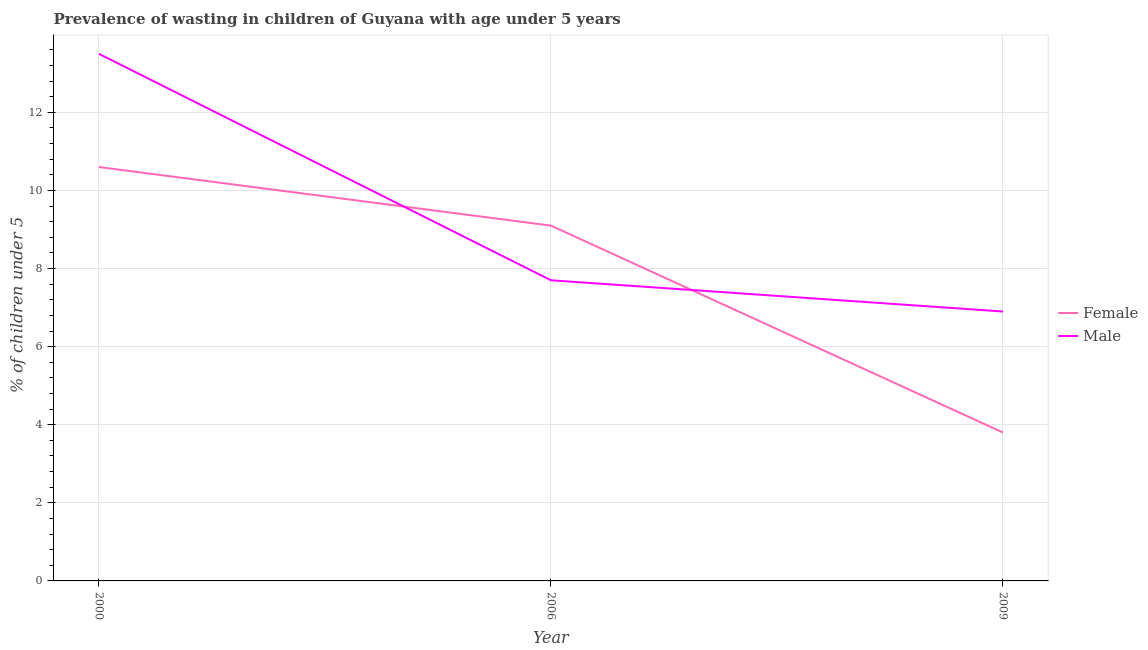Is the number of lines equal to the number of legend labels?
Offer a terse response. Yes. What is the percentage of undernourished male children in 2009?
Ensure brevity in your answer.  6.9. Across all years, what is the maximum percentage of undernourished male children?
Your answer should be compact. 13.5. Across all years, what is the minimum percentage of undernourished female children?
Give a very brief answer. 3.8. In which year was the percentage of undernourished male children minimum?
Provide a short and direct response. 2009. What is the total percentage of undernourished female children in the graph?
Keep it short and to the point. 23.5. What is the difference between the percentage of undernourished female children in 2000 and that in 2006?
Give a very brief answer. 1.5. What is the difference between the percentage of undernourished male children in 2006 and the percentage of undernourished female children in 2000?
Provide a succinct answer. -2.9. What is the average percentage of undernourished female children per year?
Give a very brief answer. 7.83. In the year 2006, what is the difference between the percentage of undernourished male children and percentage of undernourished female children?
Your answer should be very brief. -1.4. What is the ratio of the percentage of undernourished male children in 2000 to that in 2009?
Ensure brevity in your answer.  1.96. Is the percentage of undernourished female children in 2000 less than that in 2006?
Ensure brevity in your answer.  No. What is the difference between the highest and the second highest percentage of undernourished male children?
Keep it short and to the point. 5.8. What is the difference between the highest and the lowest percentage of undernourished male children?
Keep it short and to the point. 6.6. In how many years, is the percentage of undernourished male children greater than the average percentage of undernourished male children taken over all years?
Your response must be concise. 1. Is the sum of the percentage of undernourished female children in 2000 and 2009 greater than the maximum percentage of undernourished male children across all years?
Your response must be concise. Yes. Does the percentage of undernourished male children monotonically increase over the years?
Make the answer very short. No. Is the percentage of undernourished male children strictly greater than the percentage of undernourished female children over the years?
Your answer should be compact. No. Is the percentage of undernourished male children strictly less than the percentage of undernourished female children over the years?
Make the answer very short. No. How many years are there in the graph?
Your answer should be compact. 3. What is the difference between two consecutive major ticks on the Y-axis?
Offer a terse response. 2. Does the graph contain grids?
Your answer should be very brief. Yes. Where does the legend appear in the graph?
Keep it short and to the point. Center right. How many legend labels are there?
Offer a very short reply. 2. What is the title of the graph?
Offer a very short reply. Prevalence of wasting in children of Guyana with age under 5 years. Does "Electricity and heat production" appear as one of the legend labels in the graph?
Offer a very short reply. No. What is the label or title of the Y-axis?
Your answer should be compact.  % of children under 5. What is the  % of children under 5 of Female in 2000?
Offer a terse response. 10.6. What is the  % of children under 5 in Female in 2006?
Give a very brief answer. 9.1. What is the  % of children under 5 of Male in 2006?
Keep it short and to the point. 7.7. What is the  % of children under 5 in Female in 2009?
Keep it short and to the point. 3.8. What is the  % of children under 5 in Male in 2009?
Your answer should be very brief. 6.9. Across all years, what is the maximum  % of children under 5 of Female?
Your answer should be compact. 10.6. Across all years, what is the minimum  % of children under 5 of Female?
Provide a succinct answer. 3.8. Across all years, what is the minimum  % of children under 5 in Male?
Provide a succinct answer. 6.9. What is the total  % of children under 5 of Male in the graph?
Make the answer very short. 28.1. What is the difference between the  % of children under 5 in Male in 2000 and that in 2006?
Give a very brief answer. 5.8. What is the difference between the  % of children under 5 of Female in 2000 and that in 2009?
Make the answer very short. 6.8. What is the difference between the  % of children under 5 of Male in 2006 and that in 2009?
Provide a succinct answer. 0.8. What is the average  % of children under 5 of Female per year?
Keep it short and to the point. 7.83. What is the average  % of children under 5 in Male per year?
Provide a succinct answer. 9.37. In the year 2006, what is the difference between the  % of children under 5 of Female and  % of children under 5 of Male?
Give a very brief answer. 1.4. In the year 2009, what is the difference between the  % of children under 5 of Female and  % of children under 5 of Male?
Keep it short and to the point. -3.1. What is the ratio of the  % of children under 5 of Female in 2000 to that in 2006?
Give a very brief answer. 1.16. What is the ratio of the  % of children under 5 of Male in 2000 to that in 2006?
Your answer should be compact. 1.75. What is the ratio of the  % of children under 5 in Female in 2000 to that in 2009?
Offer a terse response. 2.79. What is the ratio of the  % of children under 5 of Male in 2000 to that in 2009?
Give a very brief answer. 1.96. What is the ratio of the  % of children under 5 of Female in 2006 to that in 2009?
Give a very brief answer. 2.39. What is the ratio of the  % of children under 5 of Male in 2006 to that in 2009?
Your answer should be very brief. 1.12. 